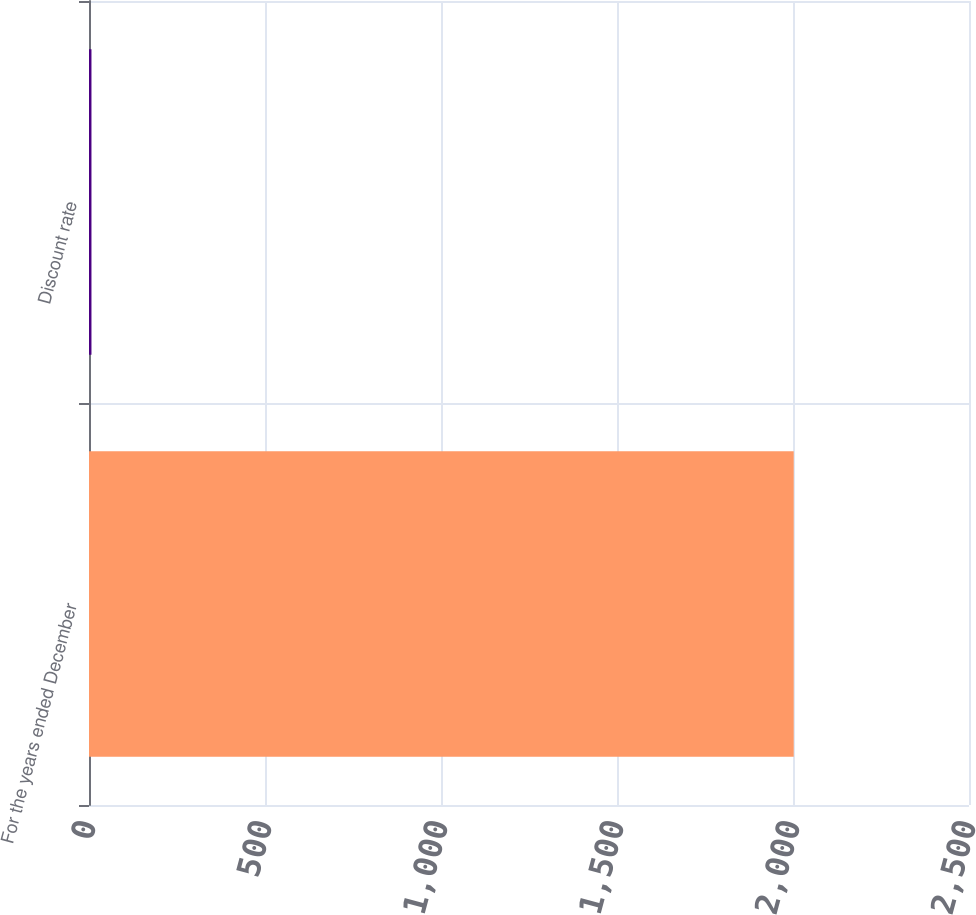Convert chart to OTSL. <chart><loc_0><loc_0><loc_500><loc_500><bar_chart><fcel>For the years ended December<fcel>Discount rate<nl><fcel>2002<fcel>7<nl></chart> 